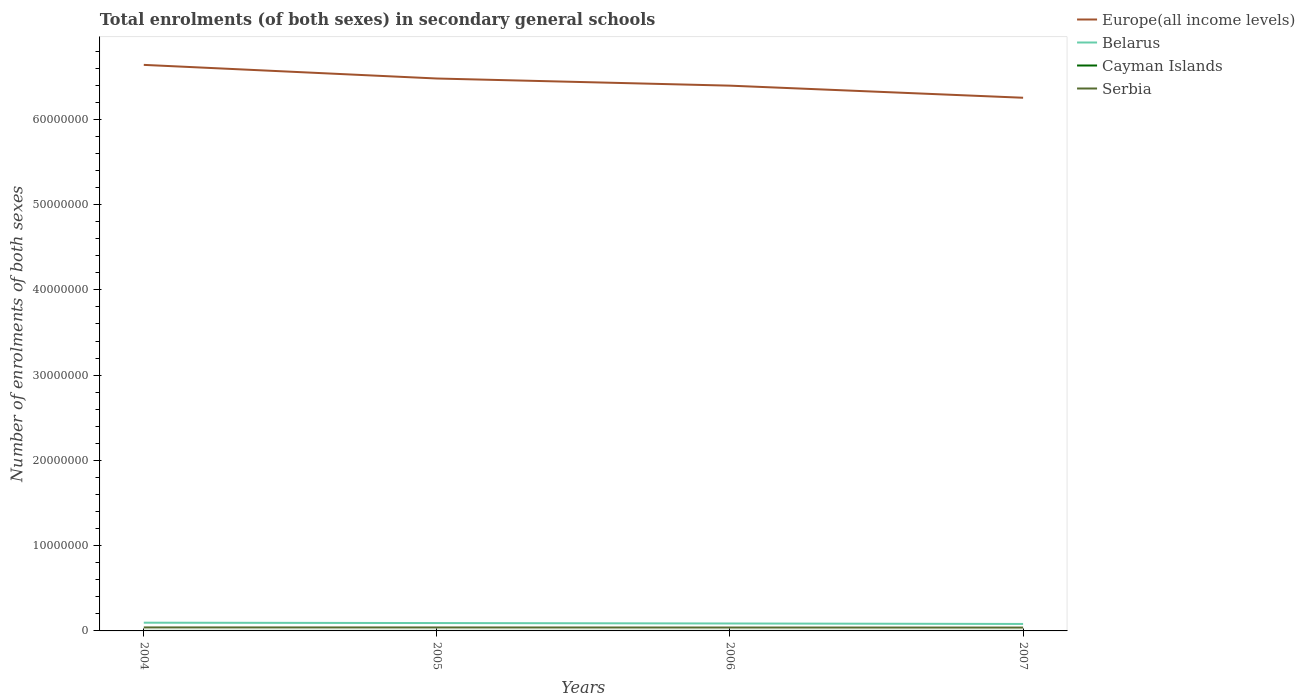How many different coloured lines are there?
Ensure brevity in your answer.  4. Is the number of lines equal to the number of legend labels?
Offer a terse response. Yes. Across all years, what is the maximum number of enrolments in secondary schools in Belarus?
Make the answer very short. 8.18e+05. What is the total number of enrolments in secondary schools in Belarus in the graph?
Offer a terse response. 1.06e+05. What is the difference between the highest and the second highest number of enrolments in secondary schools in Cayman Islands?
Provide a short and direct response. 309. Is the number of enrolments in secondary schools in Cayman Islands strictly greater than the number of enrolments in secondary schools in Belarus over the years?
Keep it short and to the point. Yes. What is the difference between two consecutive major ticks on the Y-axis?
Ensure brevity in your answer.  1.00e+07. Are the values on the major ticks of Y-axis written in scientific E-notation?
Your answer should be very brief. No. Does the graph contain any zero values?
Your response must be concise. No. Where does the legend appear in the graph?
Give a very brief answer. Top right. What is the title of the graph?
Offer a very short reply. Total enrolments (of both sexes) in secondary general schools. What is the label or title of the Y-axis?
Offer a very short reply. Number of enrolments of both sexes. What is the Number of enrolments of both sexes in Europe(all income levels) in 2004?
Your response must be concise. 6.64e+07. What is the Number of enrolments of both sexes of Belarus in 2004?
Your response must be concise. 9.65e+05. What is the Number of enrolments of both sexes of Cayman Islands in 2004?
Ensure brevity in your answer.  2701. What is the Number of enrolments of both sexes of Serbia in 2004?
Your response must be concise. 4.10e+05. What is the Number of enrolments of both sexes in Europe(all income levels) in 2005?
Offer a very short reply. 6.48e+07. What is the Number of enrolments of both sexes of Belarus in 2005?
Make the answer very short. 9.24e+05. What is the Number of enrolments of both sexes of Cayman Islands in 2005?
Keep it short and to the point. 2824. What is the Number of enrolments of both sexes of Serbia in 2005?
Offer a terse response. 4.06e+05. What is the Number of enrolments of both sexes of Europe(all income levels) in 2006?
Give a very brief answer. 6.40e+07. What is the Number of enrolments of both sexes in Belarus in 2006?
Give a very brief answer. 8.73e+05. What is the Number of enrolments of both sexes of Cayman Islands in 2006?
Your answer should be very brief. 2899. What is the Number of enrolments of both sexes of Serbia in 2006?
Offer a terse response. 4.00e+05. What is the Number of enrolments of both sexes in Europe(all income levels) in 2007?
Offer a terse response. 6.25e+07. What is the Number of enrolments of both sexes of Belarus in 2007?
Keep it short and to the point. 8.18e+05. What is the Number of enrolments of both sexes in Cayman Islands in 2007?
Offer a very short reply. 3010. What is the Number of enrolments of both sexes of Serbia in 2007?
Keep it short and to the point. 3.95e+05. Across all years, what is the maximum Number of enrolments of both sexes of Europe(all income levels)?
Offer a very short reply. 6.64e+07. Across all years, what is the maximum Number of enrolments of both sexes in Belarus?
Your answer should be compact. 9.65e+05. Across all years, what is the maximum Number of enrolments of both sexes in Cayman Islands?
Keep it short and to the point. 3010. Across all years, what is the maximum Number of enrolments of both sexes of Serbia?
Provide a succinct answer. 4.10e+05. Across all years, what is the minimum Number of enrolments of both sexes of Europe(all income levels)?
Your answer should be very brief. 6.25e+07. Across all years, what is the minimum Number of enrolments of both sexes of Belarus?
Your response must be concise. 8.18e+05. Across all years, what is the minimum Number of enrolments of both sexes in Cayman Islands?
Keep it short and to the point. 2701. Across all years, what is the minimum Number of enrolments of both sexes of Serbia?
Ensure brevity in your answer.  3.95e+05. What is the total Number of enrolments of both sexes in Europe(all income levels) in the graph?
Ensure brevity in your answer.  2.58e+08. What is the total Number of enrolments of both sexes of Belarus in the graph?
Make the answer very short. 3.58e+06. What is the total Number of enrolments of both sexes in Cayman Islands in the graph?
Offer a terse response. 1.14e+04. What is the total Number of enrolments of both sexes of Serbia in the graph?
Offer a terse response. 1.61e+06. What is the difference between the Number of enrolments of both sexes of Europe(all income levels) in 2004 and that in 2005?
Your answer should be compact. 1.60e+06. What is the difference between the Number of enrolments of both sexes in Belarus in 2004 and that in 2005?
Provide a succinct answer. 4.13e+04. What is the difference between the Number of enrolments of both sexes in Cayman Islands in 2004 and that in 2005?
Make the answer very short. -123. What is the difference between the Number of enrolments of both sexes of Serbia in 2004 and that in 2005?
Ensure brevity in your answer.  3877. What is the difference between the Number of enrolments of both sexes in Europe(all income levels) in 2004 and that in 2006?
Ensure brevity in your answer.  2.44e+06. What is the difference between the Number of enrolments of both sexes of Belarus in 2004 and that in 2006?
Keep it short and to the point. 9.20e+04. What is the difference between the Number of enrolments of both sexes of Cayman Islands in 2004 and that in 2006?
Your answer should be very brief. -198. What is the difference between the Number of enrolments of both sexes in Serbia in 2004 and that in 2006?
Your response must be concise. 1.01e+04. What is the difference between the Number of enrolments of both sexes of Europe(all income levels) in 2004 and that in 2007?
Provide a succinct answer. 3.86e+06. What is the difference between the Number of enrolments of both sexes of Belarus in 2004 and that in 2007?
Provide a succinct answer. 1.47e+05. What is the difference between the Number of enrolments of both sexes of Cayman Islands in 2004 and that in 2007?
Give a very brief answer. -309. What is the difference between the Number of enrolments of both sexes in Serbia in 2004 and that in 2007?
Your answer should be compact. 1.53e+04. What is the difference between the Number of enrolments of both sexes in Europe(all income levels) in 2005 and that in 2006?
Make the answer very short. 8.39e+05. What is the difference between the Number of enrolments of both sexes of Belarus in 2005 and that in 2006?
Provide a succinct answer. 5.07e+04. What is the difference between the Number of enrolments of both sexes of Cayman Islands in 2005 and that in 2006?
Your answer should be very brief. -75. What is the difference between the Number of enrolments of both sexes in Serbia in 2005 and that in 2006?
Your response must be concise. 6180. What is the difference between the Number of enrolments of both sexes in Europe(all income levels) in 2005 and that in 2007?
Provide a succinct answer. 2.26e+06. What is the difference between the Number of enrolments of both sexes in Belarus in 2005 and that in 2007?
Your answer should be very brief. 1.06e+05. What is the difference between the Number of enrolments of both sexes of Cayman Islands in 2005 and that in 2007?
Ensure brevity in your answer.  -186. What is the difference between the Number of enrolments of both sexes of Serbia in 2005 and that in 2007?
Your response must be concise. 1.14e+04. What is the difference between the Number of enrolments of both sexes in Europe(all income levels) in 2006 and that in 2007?
Make the answer very short. 1.42e+06. What is the difference between the Number of enrolments of both sexes of Belarus in 2006 and that in 2007?
Your response must be concise. 5.53e+04. What is the difference between the Number of enrolments of both sexes of Cayman Islands in 2006 and that in 2007?
Offer a terse response. -111. What is the difference between the Number of enrolments of both sexes in Serbia in 2006 and that in 2007?
Offer a very short reply. 5261. What is the difference between the Number of enrolments of both sexes in Europe(all income levels) in 2004 and the Number of enrolments of both sexes in Belarus in 2005?
Offer a terse response. 6.55e+07. What is the difference between the Number of enrolments of both sexes of Europe(all income levels) in 2004 and the Number of enrolments of both sexes of Cayman Islands in 2005?
Provide a short and direct response. 6.64e+07. What is the difference between the Number of enrolments of both sexes of Europe(all income levels) in 2004 and the Number of enrolments of both sexes of Serbia in 2005?
Your answer should be compact. 6.60e+07. What is the difference between the Number of enrolments of both sexes of Belarus in 2004 and the Number of enrolments of both sexes of Cayman Islands in 2005?
Make the answer very short. 9.62e+05. What is the difference between the Number of enrolments of both sexes of Belarus in 2004 and the Number of enrolments of both sexes of Serbia in 2005?
Your answer should be very brief. 5.59e+05. What is the difference between the Number of enrolments of both sexes in Cayman Islands in 2004 and the Number of enrolments of both sexes in Serbia in 2005?
Your response must be concise. -4.04e+05. What is the difference between the Number of enrolments of both sexes of Europe(all income levels) in 2004 and the Number of enrolments of both sexes of Belarus in 2006?
Keep it short and to the point. 6.55e+07. What is the difference between the Number of enrolments of both sexes of Europe(all income levels) in 2004 and the Number of enrolments of both sexes of Cayman Islands in 2006?
Provide a short and direct response. 6.64e+07. What is the difference between the Number of enrolments of both sexes in Europe(all income levels) in 2004 and the Number of enrolments of both sexes in Serbia in 2006?
Ensure brevity in your answer.  6.60e+07. What is the difference between the Number of enrolments of both sexes of Belarus in 2004 and the Number of enrolments of both sexes of Cayman Islands in 2006?
Offer a very short reply. 9.62e+05. What is the difference between the Number of enrolments of both sexes in Belarus in 2004 and the Number of enrolments of both sexes in Serbia in 2006?
Offer a very short reply. 5.65e+05. What is the difference between the Number of enrolments of both sexes in Cayman Islands in 2004 and the Number of enrolments of both sexes in Serbia in 2006?
Ensure brevity in your answer.  -3.97e+05. What is the difference between the Number of enrolments of both sexes of Europe(all income levels) in 2004 and the Number of enrolments of both sexes of Belarus in 2007?
Offer a terse response. 6.56e+07. What is the difference between the Number of enrolments of both sexes in Europe(all income levels) in 2004 and the Number of enrolments of both sexes in Cayman Islands in 2007?
Provide a succinct answer. 6.64e+07. What is the difference between the Number of enrolments of both sexes in Europe(all income levels) in 2004 and the Number of enrolments of both sexes in Serbia in 2007?
Make the answer very short. 6.60e+07. What is the difference between the Number of enrolments of both sexes of Belarus in 2004 and the Number of enrolments of both sexes of Cayman Islands in 2007?
Offer a terse response. 9.62e+05. What is the difference between the Number of enrolments of both sexes in Belarus in 2004 and the Number of enrolments of both sexes in Serbia in 2007?
Give a very brief answer. 5.70e+05. What is the difference between the Number of enrolments of both sexes of Cayman Islands in 2004 and the Number of enrolments of both sexes of Serbia in 2007?
Your response must be concise. -3.92e+05. What is the difference between the Number of enrolments of both sexes of Europe(all income levels) in 2005 and the Number of enrolments of both sexes of Belarus in 2006?
Offer a very short reply. 6.39e+07. What is the difference between the Number of enrolments of both sexes of Europe(all income levels) in 2005 and the Number of enrolments of both sexes of Cayman Islands in 2006?
Offer a terse response. 6.48e+07. What is the difference between the Number of enrolments of both sexes of Europe(all income levels) in 2005 and the Number of enrolments of both sexes of Serbia in 2006?
Your answer should be very brief. 6.44e+07. What is the difference between the Number of enrolments of both sexes in Belarus in 2005 and the Number of enrolments of both sexes in Cayman Islands in 2006?
Your answer should be compact. 9.21e+05. What is the difference between the Number of enrolments of both sexes of Belarus in 2005 and the Number of enrolments of both sexes of Serbia in 2006?
Your answer should be very brief. 5.24e+05. What is the difference between the Number of enrolments of both sexes of Cayman Islands in 2005 and the Number of enrolments of both sexes of Serbia in 2006?
Provide a succinct answer. -3.97e+05. What is the difference between the Number of enrolments of both sexes in Europe(all income levels) in 2005 and the Number of enrolments of both sexes in Belarus in 2007?
Offer a very short reply. 6.40e+07. What is the difference between the Number of enrolments of both sexes in Europe(all income levels) in 2005 and the Number of enrolments of both sexes in Cayman Islands in 2007?
Offer a very short reply. 6.48e+07. What is the difference between the Number of enrolments of both sexes in Europe(all income levels) in 2005 and the Number of enrolments of both sexes in Serbia in 2007?
Ensure brevity in your answer.  6.44e+07. What is the difference between the Number of enrolments of both sexes of Belarus in 2005 and the Number of enrolments of both sexes of Cayman Islands in 2007?
Offer a terse response. 9.21e+05. What is the difference between the Number of enrolments of both sexes in Belarus in 2005 and the Number of enrolments of both sexes in Serbia in 2007?
Provide a short and direct response. 5.29e+05. What is the difference between the Number of enrolments of both sexes in Cayman Islands in 2005 and the Number of enrolments of both sexes in Serbia in 2007?
Your response must be concise. -3.92e+05. What is the difference between the Number of enrolments of both sexes in Europe(all income levels) in 2006 and the Number of enrolments of both sexes in Belarus in 2007?
Your answer should be very brief. 6.31e+07. What is the difference between the Number of enrolments of both sexes in Europe(all income levels) in 2006 and the Number of enrolments of both sexes in Cayman Islands in 2007?
Offer a very short reply. 6.39e+07. What is the difference between the Number of enrolments of both sexes of Europe(all income levels) in 2006 and the Number of enrolments of both sexes of Serbia in 2007?
Offer a very short reply. 6.36e+07. What is the difference between the Number of enrolments of both sexes of Belarus in 2006 and the Number of enrolments of both sexes of Cayman Islands in 2007?
Your answer should be very brief. 8.70e+05. What is the difference between the Number of enrolments of both sexes of Belarus in 2006 and the Number of enrolments of both sexes of Serbia in 2007?
Give a very brief answer. 4.78e+05. What is the difference between the Number of enrolments of both sexes of Cayman Islands in 2006 and the Number of enrolments of both sexes of Serbia in 2007?
Your response must be concise. -3.92e+05. What is the average Number of enrolments of both sexes of Europe(all income levels) per year?
Give a very brief answer. 6.44e+07. What is the average Number of enrolments of both sexes in Belarus per year?
Make the answer very short. 8.95e+05. What is the average Number of enrolments of both sexes of Cayman Islands per year?
Your answer should be compact. 2858.5. What is the average Number of enrolments of both sexes of Serbia per year?
Provide a succinct answer. 4.03e+05. In the year 2004, what is the difference between the Number of enrolments of both sexes in Europe(all income levels) and Number of enrolments of both sexes in Belarus?
Provide a succinct answer. 6.54e+07. In the year 2004, what is the difference between the Number of enrolments of both sexes of Europe(all income levels) and Number of enrolments of both sexes of Cayman Islands?
Your answer should be compact. 6.64e+07. In the year 2004, what is the difference between the Number of enrolments of both sexes of Europe(all income levels) and Number of enrolments of both sexes of Serbia?
Give a very brief answer. 6.60e+07. In the year 2004, what is the difference between the Number of enrolments of both sexes of Belarus and Number of enrolments of both sexes of Cayman Islands?
Offer a very short reply. 9.62e+05. In the year 2004, what is the difference between the Number of enrolments of both sexes of Belarus and Number of enrolments of both sexes of Serbia?
Give a very brief answer. 5.55e+05. In the year 2004, what is the difference between the Number of enrolments of both sexes of Cayman Islands and Number of enrolments of both sexes of Serbia?
Offer a very short reply. -4.07e+05. In the year 2005, what is the difference between the Number of enrolments of both sexes of Europe(all income levels) and Number of enrolments of both sexes of Belarus?
Keep it short and to the point. 6.39e+07. In the year 2005, what is the difference between the Number of enrolments of both sexes of Europe(all income levels) and Number of enrolments of both sexes of Cayman Islands?
Your response must be concise. 6.48e+07. In the year 2005, what is the difference between the Number of enrolments of both sexes in Europe(all income levels) and Number of enrolments of both sexes in Serbia?
Offer a very short reply. 6.44e+07. In the year 2005, what is the difference between the Number of enrolments of both sexes in Belarus and Number of enrolments of both sexes in Cayman Islands?
Offer a very short reply. 9.21e+05. In the year 2005, what is the difference between the Number of enrolments of both sexes of Belarus and Number of enrolments of both sexes of Serbia?
Your response must be concise. 5.18e+05. In the year 2005, what is the difference between the Number of enrolments of both sexes of Cayman Islands and Number of enrolments of both sexes of Serbia?
Your response must be concise. -4.03e+05. In the year 2006, what is the difference between the Number of enrolments of both sexes of Europe(all income levels) and Number of enrolments of both sexes of Belarus?
Give a very brief answer. 6.31e+07. In the year 2006, what is the difference between the Number of enrolments of both sexes of Europe(all income levels) and Number of enrolments of both sexes of Cayman Islands?
Make the answer very short. 6.39e+07. In the year 2006, what is the difference between the Number of enrolments of both sexes in Europe(all income levels) and Number of enrolments of both sexes in Serbia?
Offer a terse response. 6.36e+07. In the year 2006, what is the difference between the Number of enrolments of both sexes in Belarus and Number of enrolments of both sexes in Cayman Islands?
Ensure brevity in your answer.  8.70e+05. In the year 2006, what is the difference between the Number of enrolments of both sexes of Belarus and Number of enrolments of both sexes of Serbia?
Ensure brevity in your answer.  4.73e+05. In the year 2006, what is the difference between the Number of enrolments of both sexes in Cayman Islands and Number of enrolments of both sexes in Serbia?
Keep it short and to the point. -3.97e+05. In the year 2007, what is the difference between the Number of enrolments of both sexes in Europe(all income levels) and Number of enrolments of both sexes in Belarus?
Offer a terse response. 6.17e+07. In the year 2007, what is the difference between the Number of enrolments of both sexes in Europe(all income levels) and Number of enrolments of both sexes in Cayman Islands?
Your response must be concise. 6.25e+07. In the year 2007, what is the difference between the Number of enrolments of both sexes in Europe(all income levels) and Number of enrolments of both sexes in Serbia?
Offer a terse response. 6.21e+07. In the year 2007, what is the difference between the Number of enrolments of both sexes of Belarus and Number of enrolments of both sexes of Cayman Islands?
Your response must be concise. 8.15e+05. In the year 2007, what is the difference between the Number of enrolments of both sexes in Belarus and Number of enrolments of both sexes in Serbia?
Your response must be concise. 4.23e+05. In the year 2007, what is the difference between the Number of enrolments of both sexes in Cayman Islands and Number of enrolments of both sexes in Serbia?
Make the answer very short. -3.92e+05. What is the ratio of the Number of enrolments of both sexes of Europe(all income levels) in 2004 to that in 2005?
Keep it short and to the point. 1.02. What is the ratio of the Number of enrolments of both sexes of Belarus in 2004 to that in 2005?
Make the answer very short. 1.04. What is the ratio of the Number of enrolments of both sexes in Cayman Islands in 2004 to that in 2005?
Offer a terse response. 0.96. What is the ratio of the Number of enrolments of both sexes in Serbia in 2004 to that in 2005?
Provide a succinct answer. 1.01. What is the ratio of the Number of enrolments of both sexes in Europe(all income levels) in 2004 to that in 2006?
Keep it short and to the point. 1.04. What is the ratio of the Number of enrolments of both sexes of Belarus in 2004 to that in 2006?
Offer a very short reply. 1.11. What is the ratio of the Number of enrolments of both sexes of Cayman Islands in 2004 to that in 2006?
Give a very brief answer. 0.93. What is the ratio of the Number of enrolments of both sexes of Serbia in 2004 to that in 2006?
Make the answer very short. 1.03. What is the ratio of the Number of enrolments of both sexes of Europe(all income levels) in 2004 to that in 2007?
Provide a succinct answer. 1.06. What is the ratio of the Number of enrolments of both sexes of Belarus in 2004 to that in 2007?
Keep it short and to the point. 1.18. What is the ratio of the Number of enrolments of both sexes in Cayman Islands in 2004 to that in 2007?
Offer a terse response. 0.9. What is the ratio of the Number of enrolments of both sexes of Serbia in 2004 to that in 2007?
Provide a succinct answer. 1.04. What is the ratio of the Number of enrolments of both sexes in Europe(all income levels) in 2005 to that in 2006?
Provide a succinct answer. 1.01. What is the ratio of the Number of enrolments of both sexes in Belarus in 2005 to that in 2006?
Offer a terse response. 1.06. What is the ratio of the Number of enrolments of both sexes in Cayman Islands in 2005 to that in 2006?
Your response must be concise. 0.97. What is the ratio of the Number of enrolments of both sexes in Serbia in 2005 to that in 2006?
Your answer should be very brief. 1.02. What is the ratio of the Number of enrolments of both sexes in Europe(all income levels) in 2005 to that in 2007?
Your response must be concise. 1.04. What is the ratio of the Number of enrolments of both sexes of Belarus in 2005 to that in 2007?
Make the answer very short. 1.13. What is the ratio of the Number of enrolments of both sexes in Cayman Islands in 2005 to that in 2007?
Make the answer very short. 0.94. What is the ratio of the Number of enrolments of both sexes in Serbia in 2005 to that in 2007?
Make the answer very short. 1.03. What is the ratio of the Number of enrolments of both sexes of Europe(all income levels) in 2006 to that in 2007?
Your answer should be compact. 1.02. What is the ratio of the Number of enrolments of both sexes of Belarus in 2006 to that in 2007?
Your response must be concise. 1.07. What is the ratio of the Number of enrolments of both sexes of Cayman Islands in 2006 to that in 2007?
Your answer should be very brief. 0.96. What is the ratio of the Number of enrolments of both sexes of Serbia in 2006 to that in 2007?
Your answer should be very brief. 1.01. What is the difference between the highest and the second highest Number of enrolments of both sexes of Europe(all income levels)?
Offer a very short reply. 1.60e+06. What is the difference between the highest and the second highest Number of enrolments of both sexes of Belarus?
Offer a very short reply. 4.13e+04. What is the difference between the highest and the second highest Number of enrolments of both sexes in Cayman Islands?
Provide a succinct answer. 111. What is the difference between the highest and the second highest Number of enrolments of both sexes in Serbia?
Make the answer very short. 3877. What is the difference between the highest and the lowest Number of enrolments of both sexes of Europe(all income levels)?
Keep it short and to the point. 3.86e+06. What is the difference between the highest and the lowest Number of enrolments of both sexes in Belarus?
Provide a short and direct response. 1.47e+05. What is the difference between the highest and the lowest Number of enrolments of both sexes in Cayman Islands?
Offer a terse response. 309. What is the difference between the highest and the lowest Number of enrolments of both sexes in Serbia?
Offer a very short reply. 1.53e+04. 